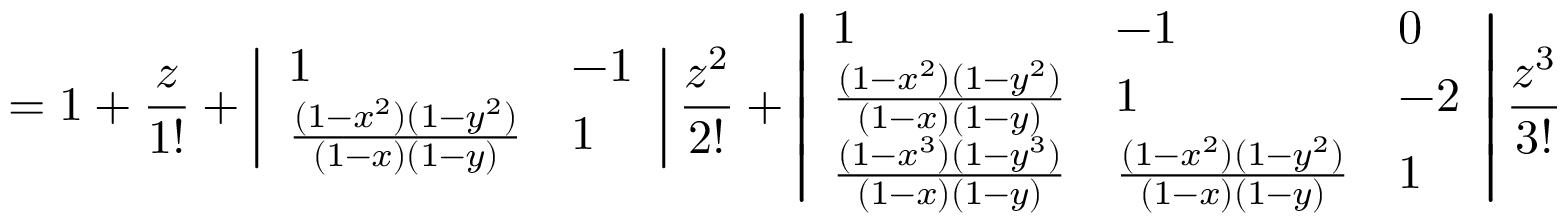<formula> <loc_0><loc_0><loc_500><loc_500>= 1 + \frac { z } { 1 ! } + \left | \begin{array} { l l } { 1 } & { - 1 } \\ { \frac { ( 1 - x ^ { 2 } ) ( 1 - y ^ { 2 } ) } { ( 1 - x ) ( 1 - y ) } } & { 1 } \end{array} \right | \frac { z ^ { 2 } } { 2 ! } + \left | \begin{array} { l l l } { 1 } & { - 1 } & { 0 } \\ { \frac { ( 1 - x ^ { 2 } ) ( 1 - y ^ { 2 } ) } { ( 1 - x ) ( 1 - y ) } } & { 1 } & { - 2 } \\ { \frac { ( 1 - x ^ { 3 } ) ( 1 - y ^ { 3 } ) } { ( 1 - x ) ( 1 - y ) } } & { \frac { ( 1 - x ^ { 2 } ) ( 1 - y ^ { 2 } ) } { ( 1 - x ) ( 1 - y ) } } & { 1 } \end{array} \right | \frac { z ^ { 3 } } { 3 ! }</formula> 